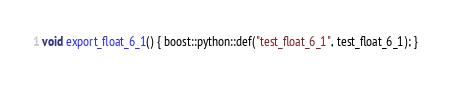Convert code to text. <code><loc_0><loc_0><loc_500><loc_500><_C++_>void export_float_6_1() { boost::python::def("test_float_6_1", test_float_6_1); }
</code> 